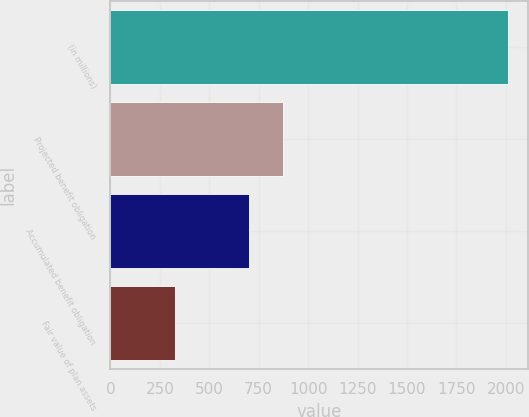Convert chart to OTSL. <chart><loc_0><loc_0><loc_500><loc_500><bar_chart><fcel>(in millions)<fcel>Projected benefit obligation<fcel>Accumulated benefit obligation<fcel>Fair value of plan assets<nl><fcel>2013<fcel>871.6<fcel>703<fcel>327<nl></chart> 